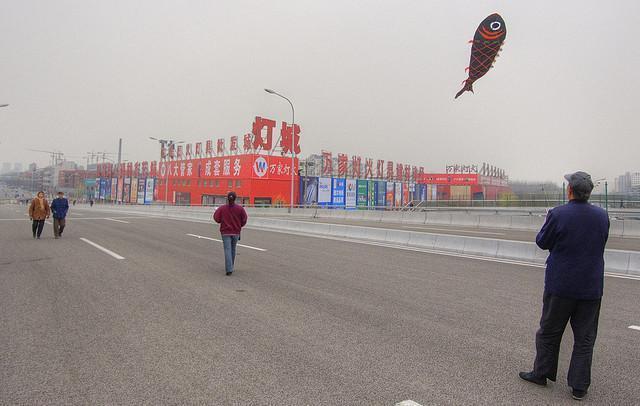How many orange boats are there?
Give a very brief answer. 0. 